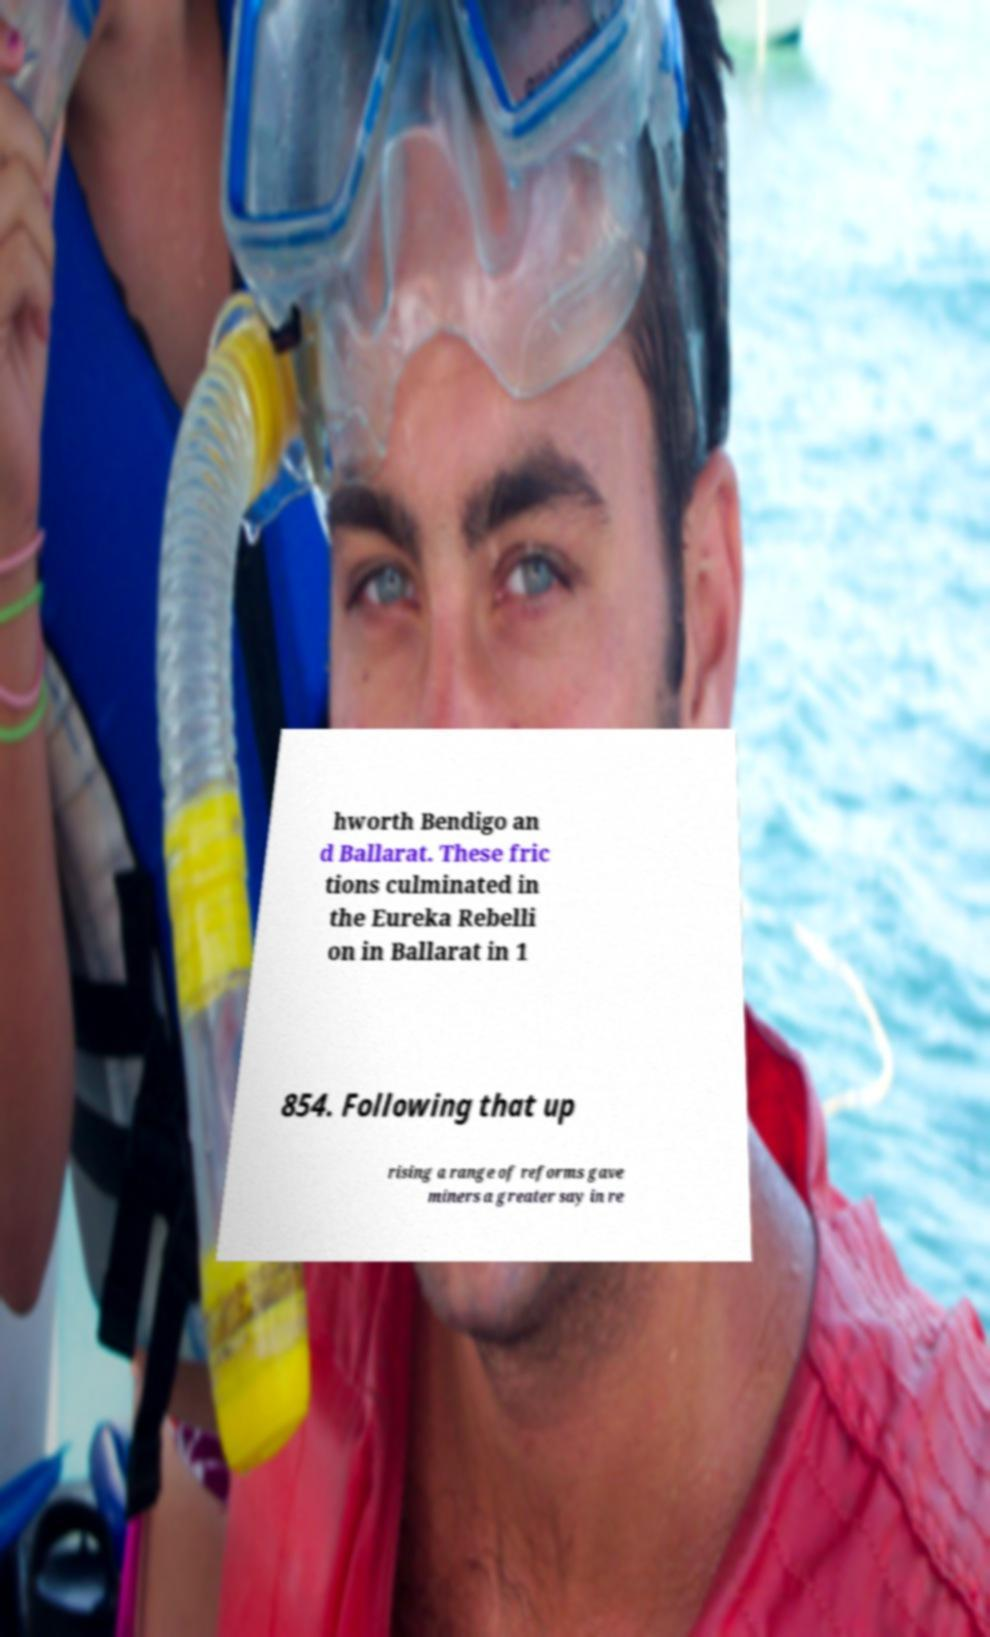What messages or text are displayed in this image? I need them in a readable, typed format. hworth Bendigo an d Ballarat. These fric tions culminated in the Eureka Rebelli on in Ballarat in 1 854. Following that up rising a range of reforms gave miners a greater say in re 